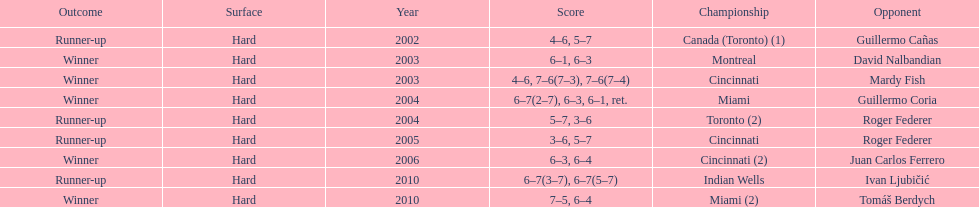How many times has he been runner-up? 4. 